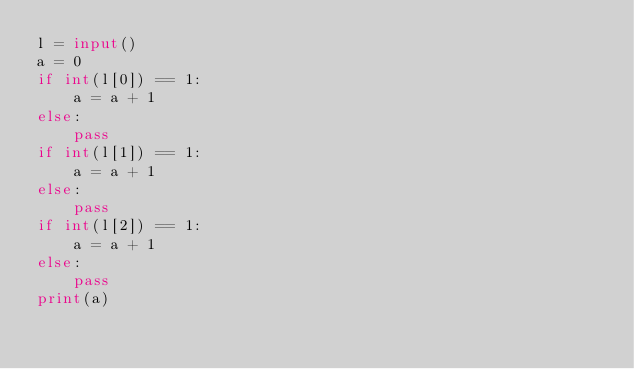<code> <loc_0><loc_0><loc_500><loc_500><_Python_>l = input()
a = 0
if int(l[0]) == 1:
    a = a + 1
else:
    pass
if int(l[1]) == 1:
    a = a + 1
else:
    pass
if int(l[2]) == 1:
    a = a + 1
else:
    pass
print(a)</code> 